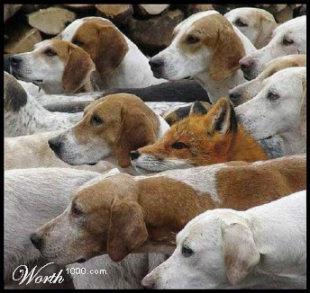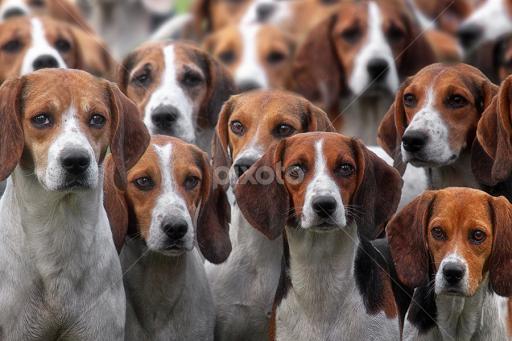The first image is the image on the left, the second image is the image on the right. For the images shown, is this caption "A man in a cap and blazer stands holding a whip-shaped item, with a pack of beagles around him." true? Answer yes or no. No. The first image is the image on the left, the second image is the image on the right. Given the left and right images, does the statement "A man is standing with the dogs in the image on the left." hold true? Answer yes or no. No. 